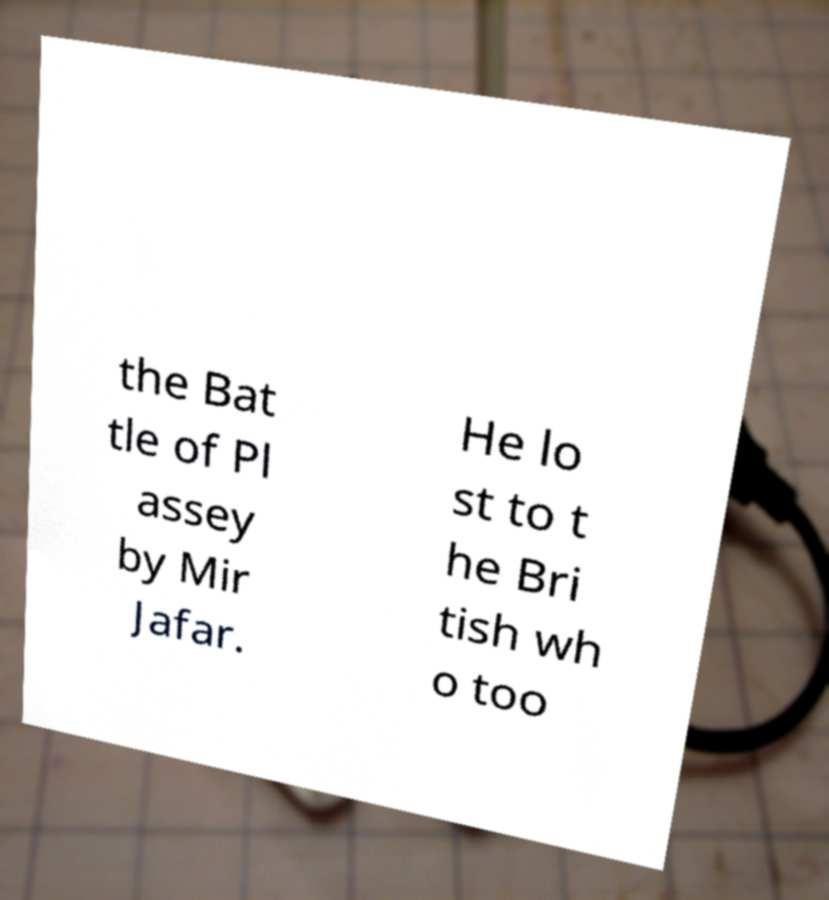Could you extract and type out the text from this image? the Bat tle of Pl assey by Mir Jafar. He lo st to t he Bri tish wh o too 